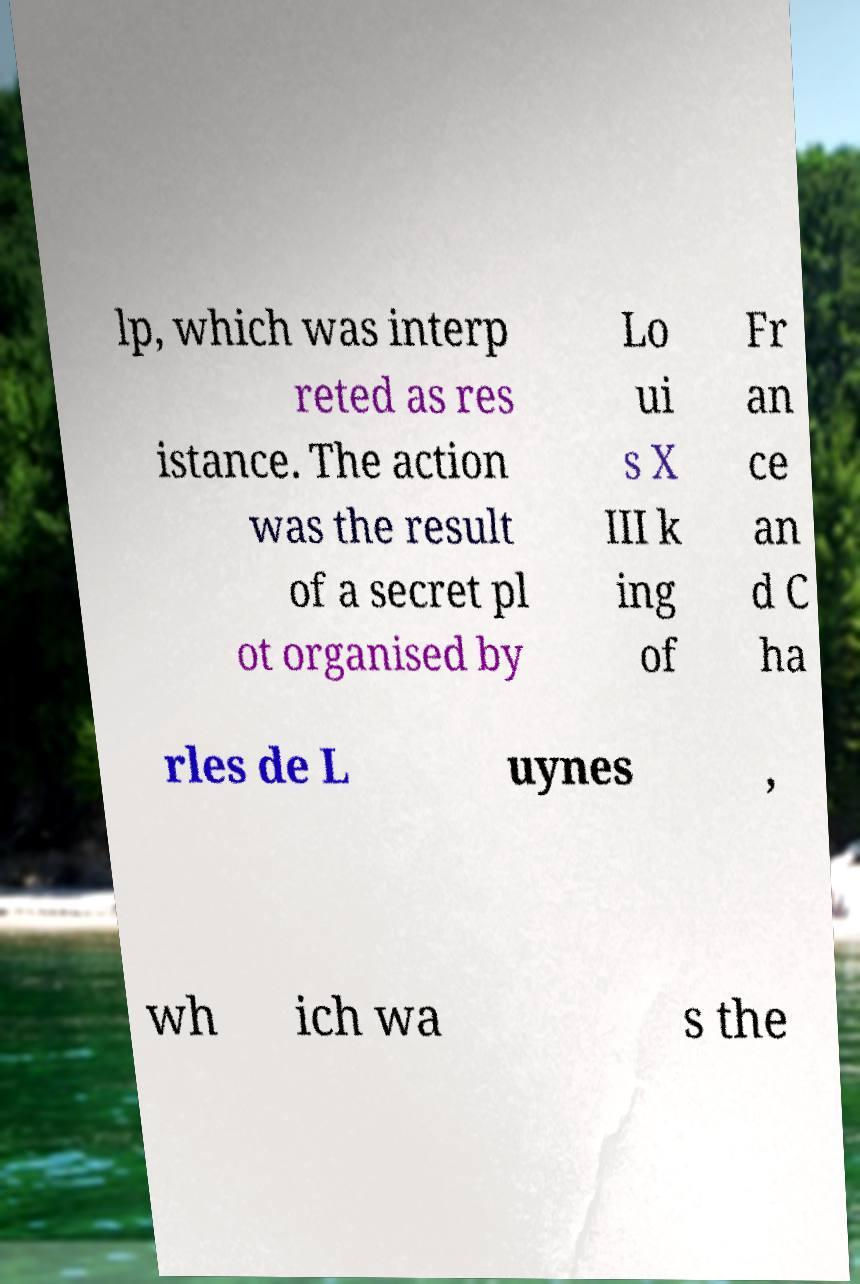Could you assist in decoding the text presented in this image and type it out clearly? lp, which was interp reted as res istance. The action was the result of a secret pl ot organised by Lo ui s X III k ing of Fr an ce an d C ha rles de L uynes , wh ich wa s the 